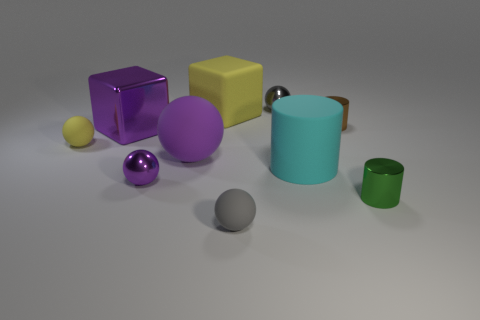How many purple balls must be subtracted to get 1 purple balls? 1 Subtract all large cylinders. How many cylinders are left? 2 Subtract all yellow cubes. How many cubes are left? 1 Subtract all gray cubes. How many gray balls are left? 2 Subtract 1 balls. How many balls are left? 4 Subtract all large gray metallic spheres. Subtract all small rubber balls. How many objects are left? 8 Add 2 cyan rubber objects. How many cyan rubber objects are left? 3 Add 3 blue matte cylinders. How many blue matte cylinders exist? 3 Subtract 1 purple blocks. How many objects are left? 9 Subtract all cylinders. How many objects are left? 7 